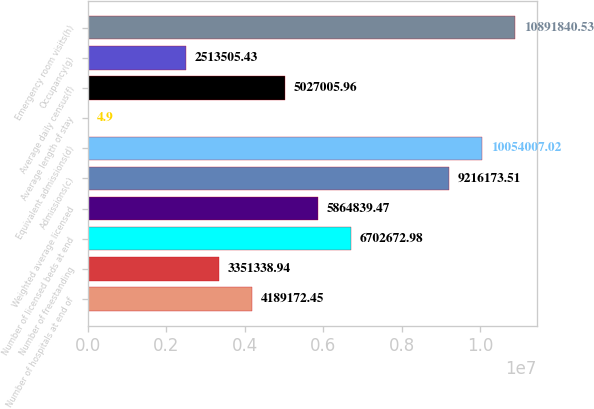Convert chart to OTSL. <chart><loc_0><loc_0><loc_500><loc_500><bar_chart><fcel>Number of hospitals at end of<fcel>Number of freestanding<fcel>Number of licensed beds at end<fcel>Weighted average licensed<fcel>Admissions(c)<fcel>Equivalent admissions(d)<fcel>Average length of stay<fcel>Average daily census(f)<fcel>Occupancy(g)<fcel>Emergency room visits(h)<nl><fcel>4.18917e+06<fcel>3.35134e+06<fcel>6.70267e+06<fcel>5.86484e+06<fcel>9.21617e+06<fcel>1.0054e+07<fcel>4.9<fcel>5.02701e+06<fcel>2.51351e+06<fcel>1.08918e+07<nl></chart> 